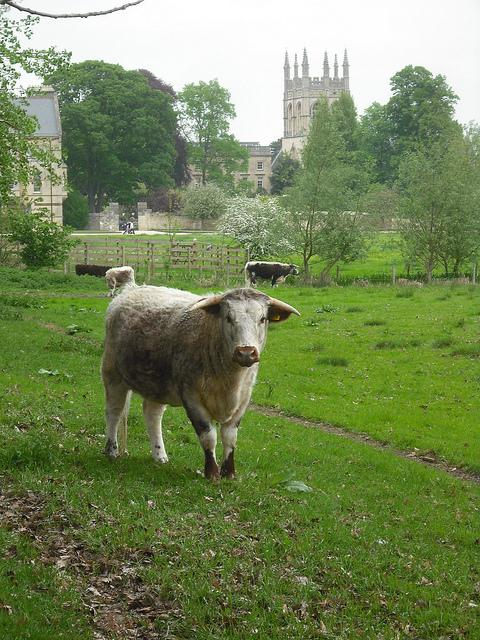What type of animal is present on the grass? Please explain your reasoning. cows. There are some fluffy white cows on the grass. 